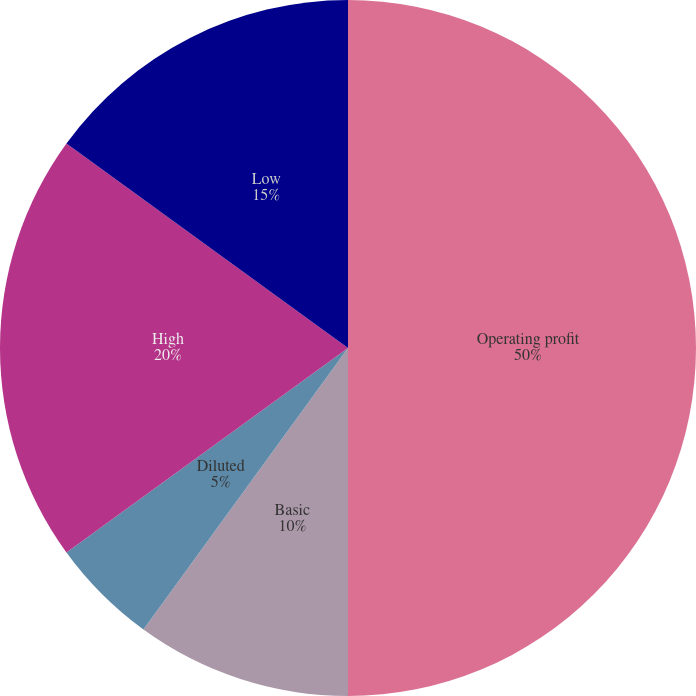Convert chart to OTSL. <chart><loc_0><loc_0><loc_500><loc_500><pie_chart><fcel>Operating profit<fcel>Basic<fcel>Diluted<fcel>High<fcel>Low<fcel>Cash dividends declared<nl><fcel>50.0%<fcel>10.0%<fcel>5.0%<fcel>20.0%<fcel>15.0%<fcel>0.0%<nl></chart> 